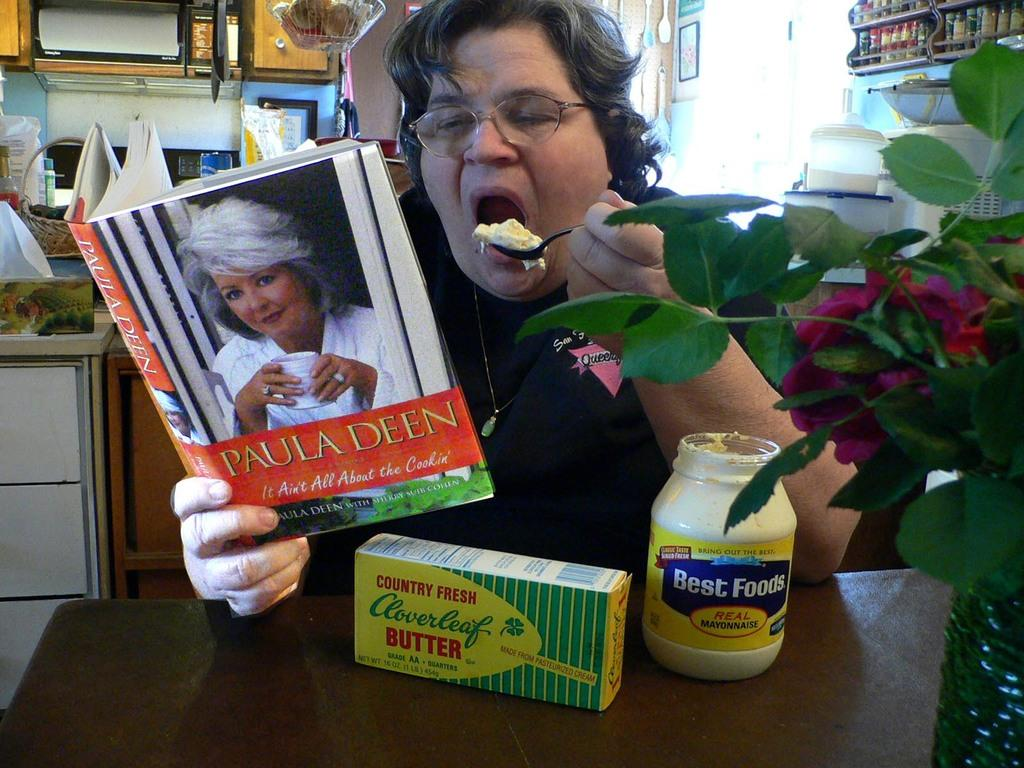Provide a one-sentence caption for the provided image. The book that is being read is from Paula Deen. 